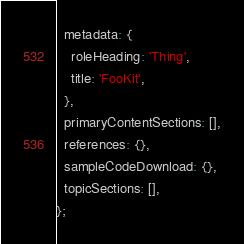<code> <loc_0><loc_0><loc_500><loc_500><_JavaScript_>  metadata: {
    roleHeading: 'Thing',
    title: 'FooKit',
  },
  primaryContentSections: [],
  references: {},
  sampleCodeDownload: {},
  topicSections: [],
};
</code> 